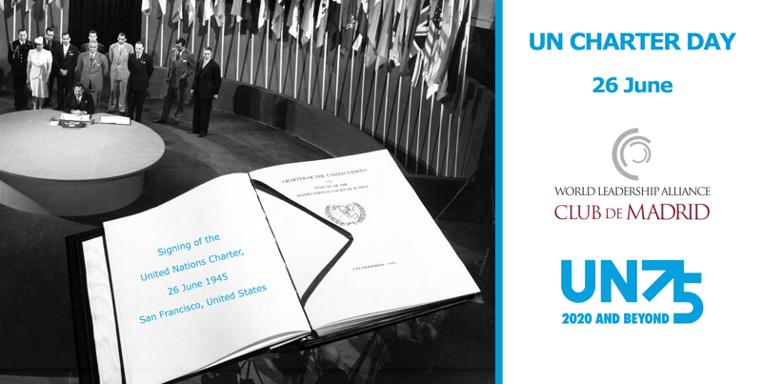What date is UN Charter Day celebrated?
 UN Charter Day is celebrated on 26th June. What organization is involved in this event, as indicated in the image? The World Leadership Alliance Club de Madrid is involved in this event. When and where was the United Nations Charter signed? The United Nations Charter was signed on 26 June 1945 in San Francisco, United States. 